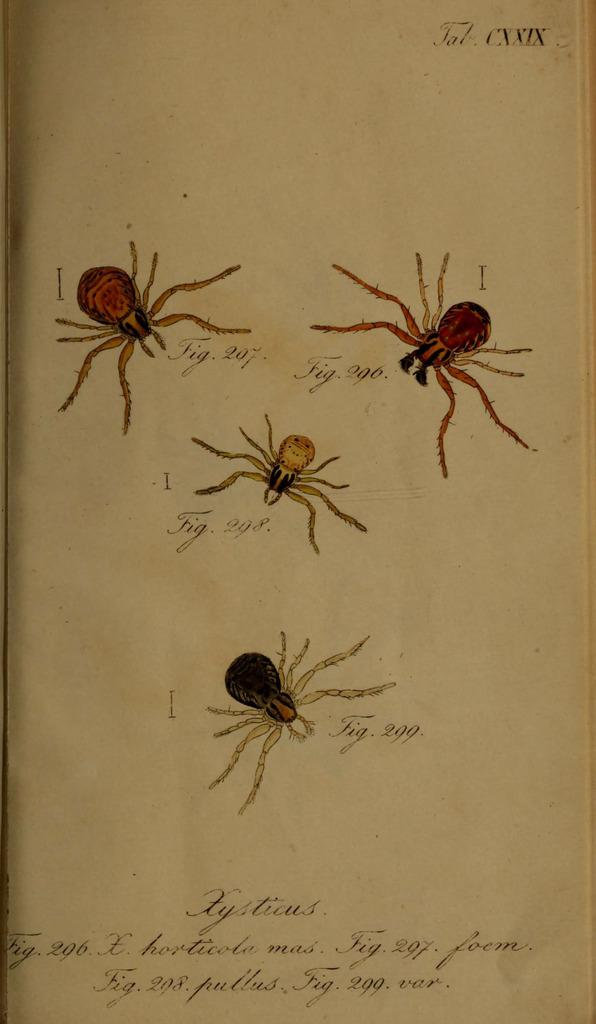What is present in the image related to written material? There is a paper in the image. What is the content of the paper? The paper contains diagrams of insects and text. What is the creator's wealth based on the information provided in the image? There is no information about the creator's wealth in the image, as it only contains diagrams of insects and text. 